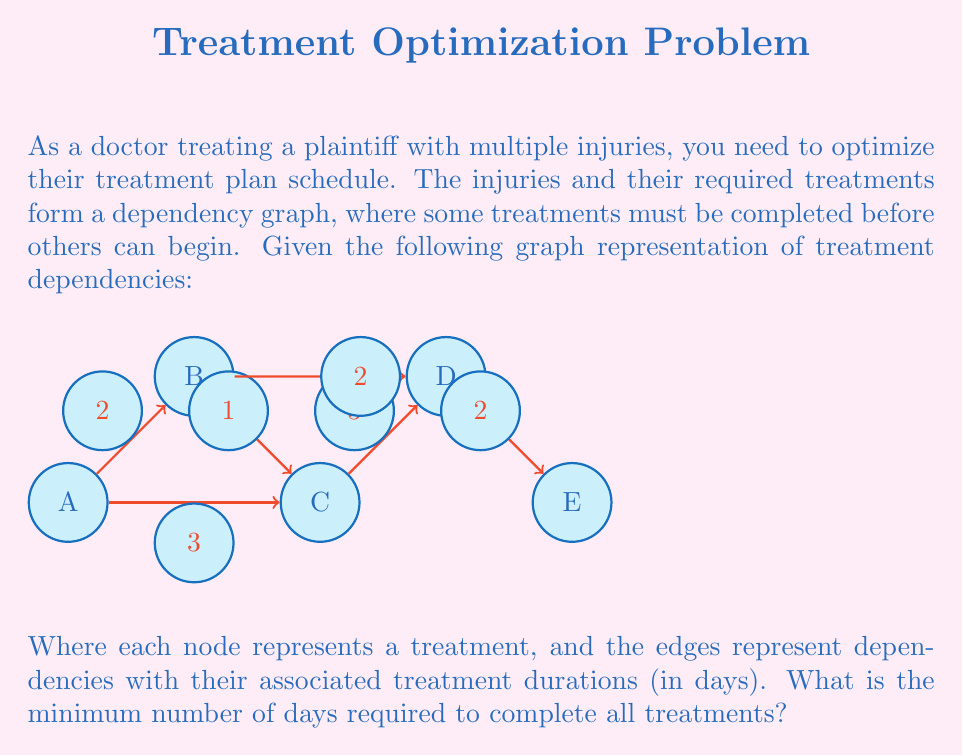Solve this math problem. To solve this problem, we need to find the critical path in the given directed acyclic graph (DAG). The critical path is the longest path from the start node to the end node, which determines the minimum time required to complete all treatments.

Let's solve this step-by-step using the longest path algorithm:

1) First, we topologically sort the nodes: A, B, C, D, E

2) Initialize distances:
   $d(A) = 0$
   $d(B) = d(C) = d(D) = d(E) = -\infty$

3) Process nodes in topological order:

   For A:
   $d(B) = \max(d(B), d(A) + 2) = 2$
   $d(C) = \max(d(C), d(A) + 3) = 3$

   For B:
   $d(C) = \max(d(C), d(B) + 1) = 3$
   $d(D) = \max(d(D), d(B) + 2) = 4$

   For C:
   $d(D) = \max(d(D), d(C) + 3) = 6$

   For D:
   $d(E) = \max(d(E), d(D) + 2) = 8$

   For E: (no outgoing edges)

4) The longest path ends at E with a distance of 8.

Therefore, the minimum number of days required to complete all treatments is 8 days.
Answer: 8 days 